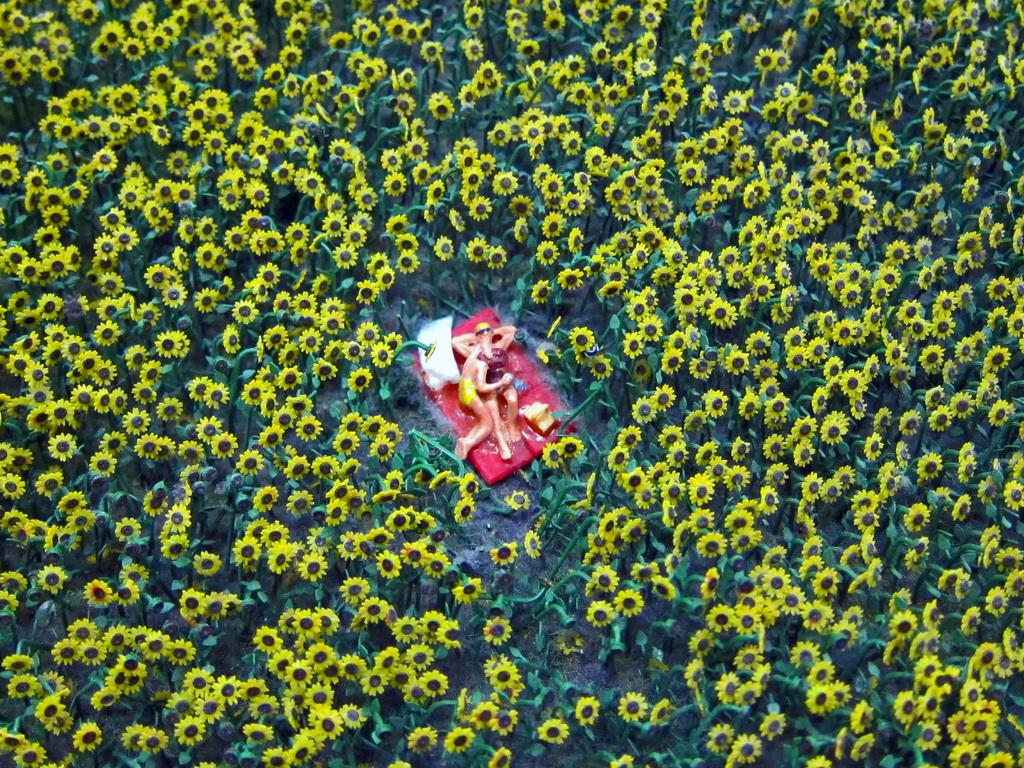What are the two people in the image doing? There is a couple lying down in the image. What type of plants can be seen in the image? There are sunflower plants in the image. What type of frame surrounds the couple in the image? There is no frame surrounding the couple in the image; they are lying down in an open space. 